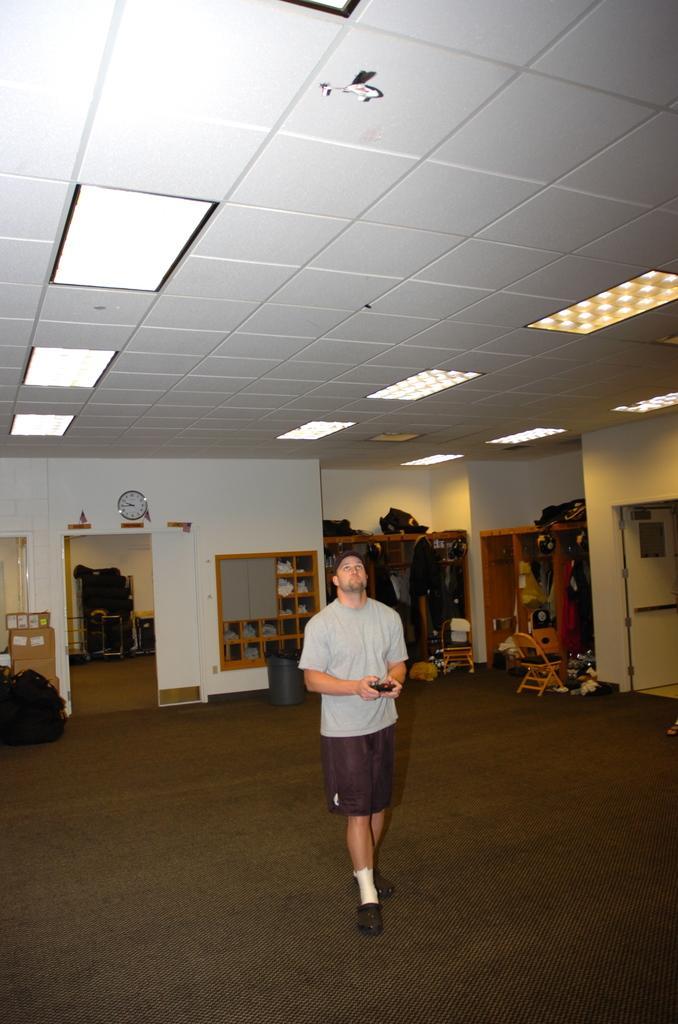In one or two sentences, can you explain what this image depicts? In this image center there is one person standing and he is holding a mobile, and in the background there are some cupboards. In the cupboards there are some clothes, and there is a chair, door, wall and clock, boxes and some bags. And at the top there is ceiling and lights, at the bottom there is floor. 